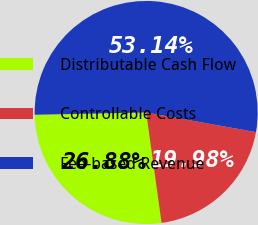<chart> <loc_0><loc_0><loc_500><loc_500><pie_chart><fcel>Distributable Cash Flow<fcel>Controllable Costs<fcel>Fee-based Revenue<nl><fcel>26.88%<fcel>19.98%<fcel>53.14%<nl></chart> 